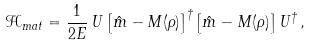<formula> <loc_0><loc_0><loc_500><loc_500>\mathcal { H } _ { m a t } = \frac { 1 } { 2 E } \, U \left [ \hat { m } - M ( \rho ) \right ] ^ { \dagger } \left [ \hat { m } - M ( \rho ) \right ] U ^ { \dagger } \, ,</formula> 